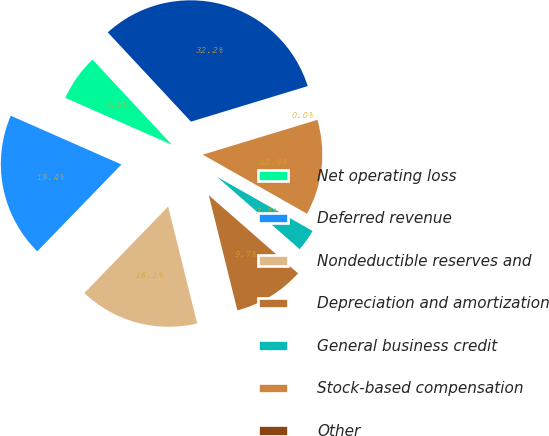Convert chart. <chart><loc_0><loc_0><loc_500><loc_500><pie_chart><fcel>Net operating loss<fcel>Deferred revenue<fcel>Nondeductible reserves and<fcel>Depreciation and amortization<fcel>General business credit<fcel>Stock-based compensation<fcel>Other<fcel>Total deferred tax assets<nl><fcel>6.46%<fcel>19.35%<fcel>16.12%<fcel>9.68%<fcel>3.24%<fcel>12.9%<fcel>0.01%<fcel>32.23%<nl></chart> 